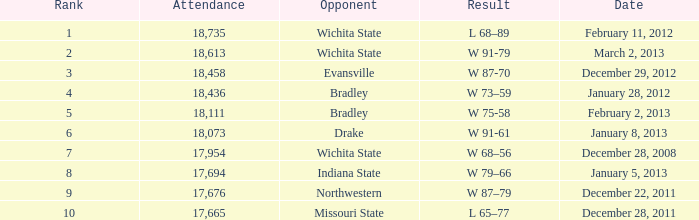What's the rank when attendance was less than 18,073 and having Northwestern as an opponent? 9.0. 